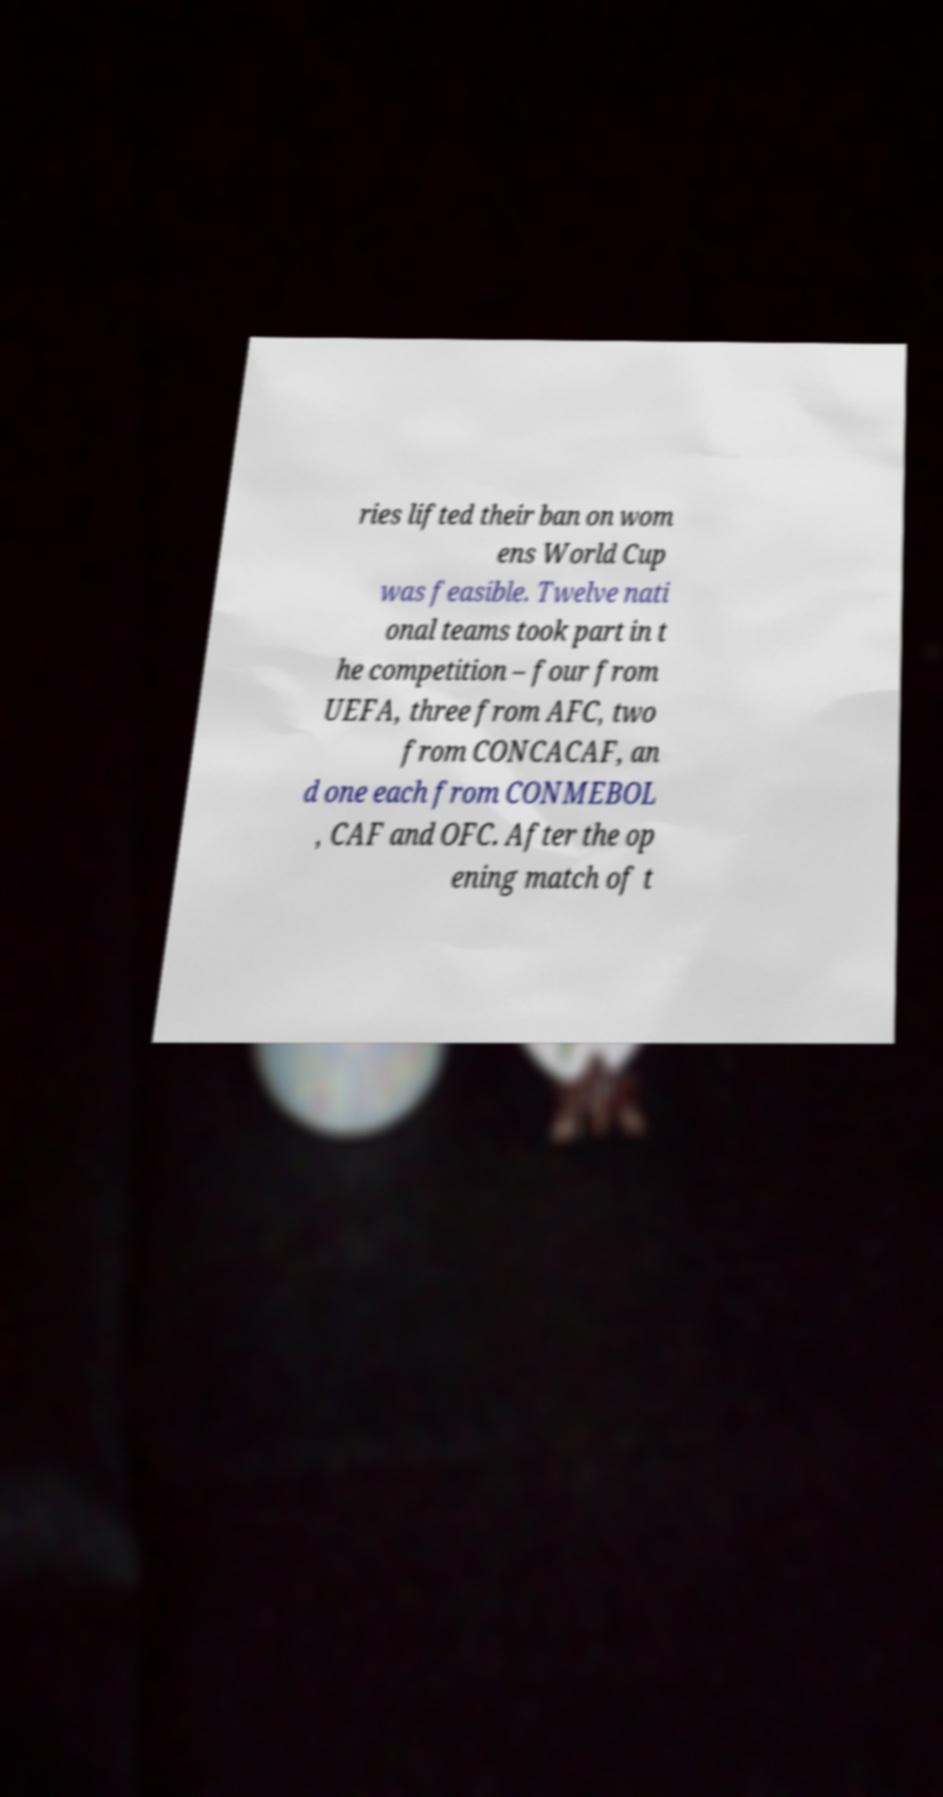Could you extract and type out the text from this image? ries lifted their ban on wom ens World Cup was feasible. Twelve nati onal teams took part in t he competition – four from UEFA, three from AFC, two from CONCACAF, an d one each from CONMEBOL , CAF and OFC. After the op ening match of t 